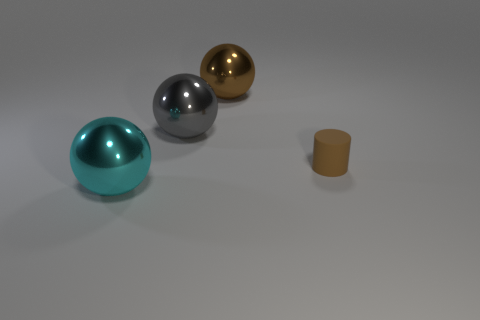There is a brown thing right of the large metallic sphere that is behind the large gray thing; what is it made of?
Keep it short and to the point. Rubber. Is the number of brown spheres that are to the left of the large gray shiny thing greater than the number of brown balls?
Keep it short and to the point. No. How many other objects are there of the same size as the gray metal sphere?
Give a very brief answer. 2. There is a metallic ball that is in front of the brown object that is in front of the big brown object that is behind the brown rubber thing; what is its color?
Make the answer very short. Cyan. What number of large cyan objects are on the left side of the brown object to the right of the brown thing on the left side of the small brown cylinder?
Give a very brief answer. 1. Are there any other things that are the same color as the small cylinder?
Your answer should be compact. Yes. There is a sphere that is in front of the gray ball; is it the same size as the small brown thing?
Give a very brief answer. No. There is a brown thing in front of the large brown object; how many metal balls are to the left of it?
Provide a succinct answer. 3. Is there a big brown object that is in front of the object to the right of the big shiny thing that is to the right of the large gray shiny object?
Provide a succinct answer. No. There is a gray thing that is the same shape as the big brown object; what is it made of?
Ensure brevity in your answer.  Metal. 